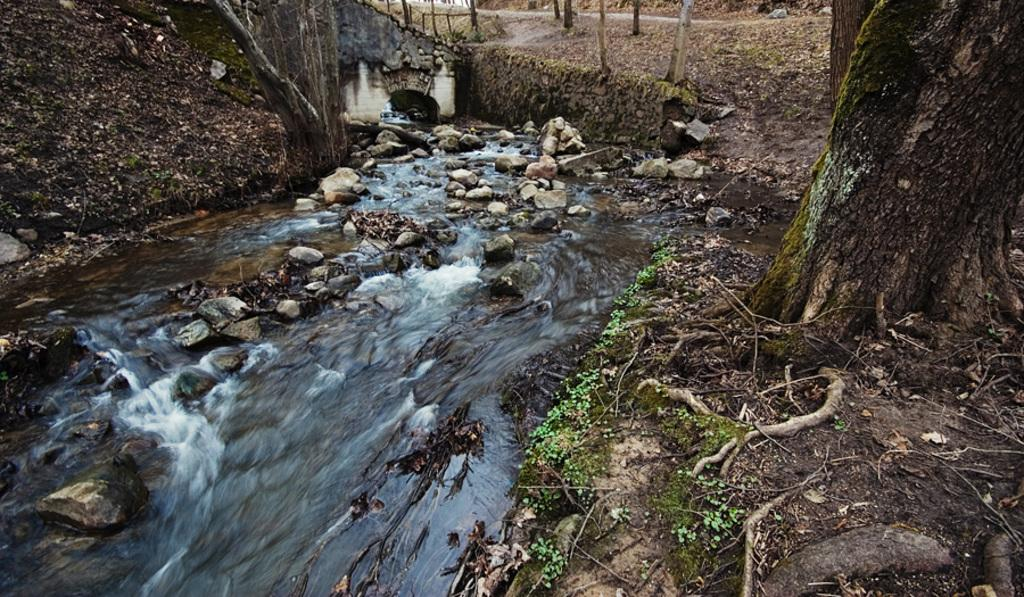What can be seen in large quantities in the image? There are many trunks of trees in the image. What natural feature is present in the image? There is a water flow in the image. What type of landscape elements are present in the image? There are many stones and plants in the image. What man-made feature can be seen in the image? There is a road in the image. Where is the pickle located in the image? There is no pickle present in the image. What type of meeting is taking place in the image? There is no meeting present in the image. 